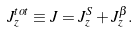Convert formula to latex. <formula><loc_0><loc_0><loc_500><loc_500>J _ { z } ^ { t o t } \equiv J = J _ { z } ^ { S } + J _ { z } ^ { \beta } .</formula> 